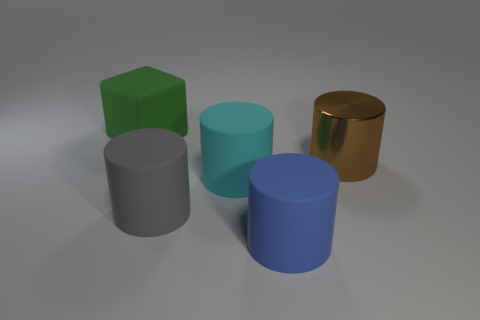Subtract all cyan rubber cylinders. How many cylinders are left? 3 Add 2 blue objects. How many objects exist? 7 Subtract all cyan cylinders. How many cylinders are left? 3 Subtract all blocks. How many objects are left? 4 Subtract 3 cylinders. How many cylinders are left? 1 Subtract 0 cyan cubes. How many objects are left? 5 Subtract all blue cylinders. Subtract all blue spheres. How many cylinders are left? 3 Subtract all tiny brown shiny cubes. Subtract all green matte objects. How many objects are left? 4 Add 1 large gray things. How many large gray things are left? 2 Add 2 large blue things. How many large blue things exist? 3 